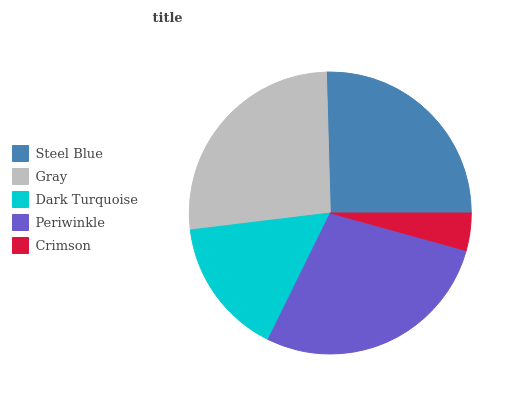Is Crimson the minimum?
Answer yes or no. Yes. Is Periwinkle the maximum?
Answer yes or no. Yes. Is Gray the minimum?
Answer yes or no. No. Is Gray the maximum?
Answer yes or no. No. Is Gray greater than Steel Blue?
Answer yes or no. Yes. Is Steel Blue less than Gray?
Answer yes or no. Yes. Is Steel Blue greater than Gray?
Answer yes or no. No. Is Gray less than Steel Blue?
Answer yes or no. No. Is Steel Blue the high median?
Answer yes or no. Yes. Is Steel Blue the low median?
Answer yes or no. Yes. Is Gray the high median?
Answer yes or no. No. Is Crimson the low median?
Answer yes or no. No. 